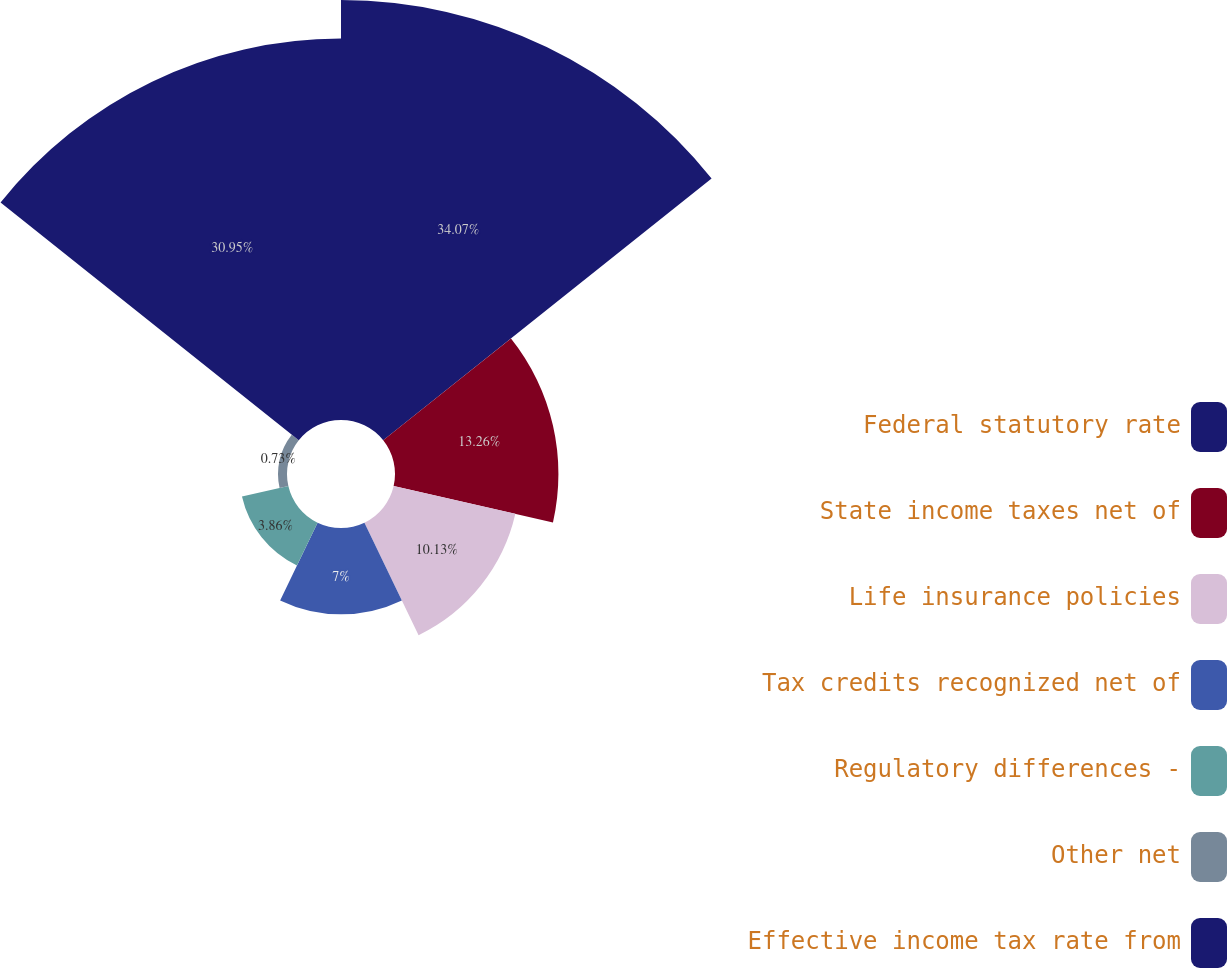<chart> <loc_0><loc_0><loc_500><loc_500><pie_chart><fcel>Federal statutory rate<fcel>State income taxes net of<fcel>Life insurance policies<fcel>Tax credits recognized net of<fcel>Regulatory differences -<fcel>Other net<fcel>Effective income tax rate from<nl><fcel>34.08%<fcel>13.26%<fcel>10.13%<fcel>7.0%<fcel>3.86%<fcel>0.73%<fcel>30.95%<nl></chart> 